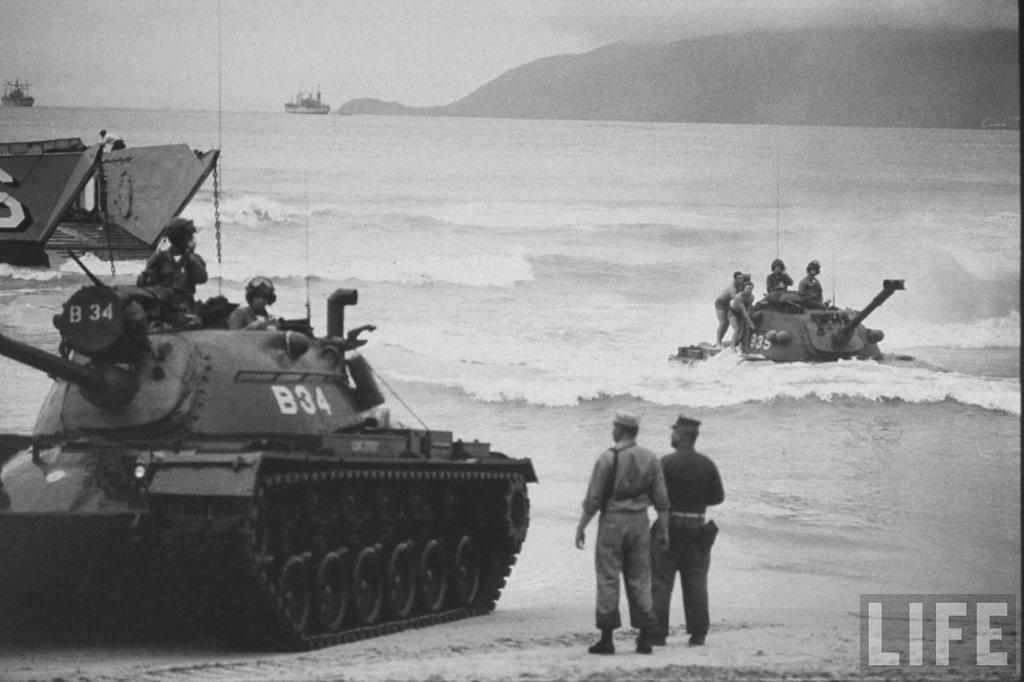What are the persons in the image doing? There are persons sitting in a military tanker and standing. What can be seen in the background of the image? The background of the image includes water. What is the color scheme of the image? The image is in black and white. What type of doctor can be seen examining the jam in the image? There is no doctor or jam present in the image. What is the scene depicted in the image? The image does not depict a scene; it shows persons sitting in a military tanker and standing, with a background of water. 